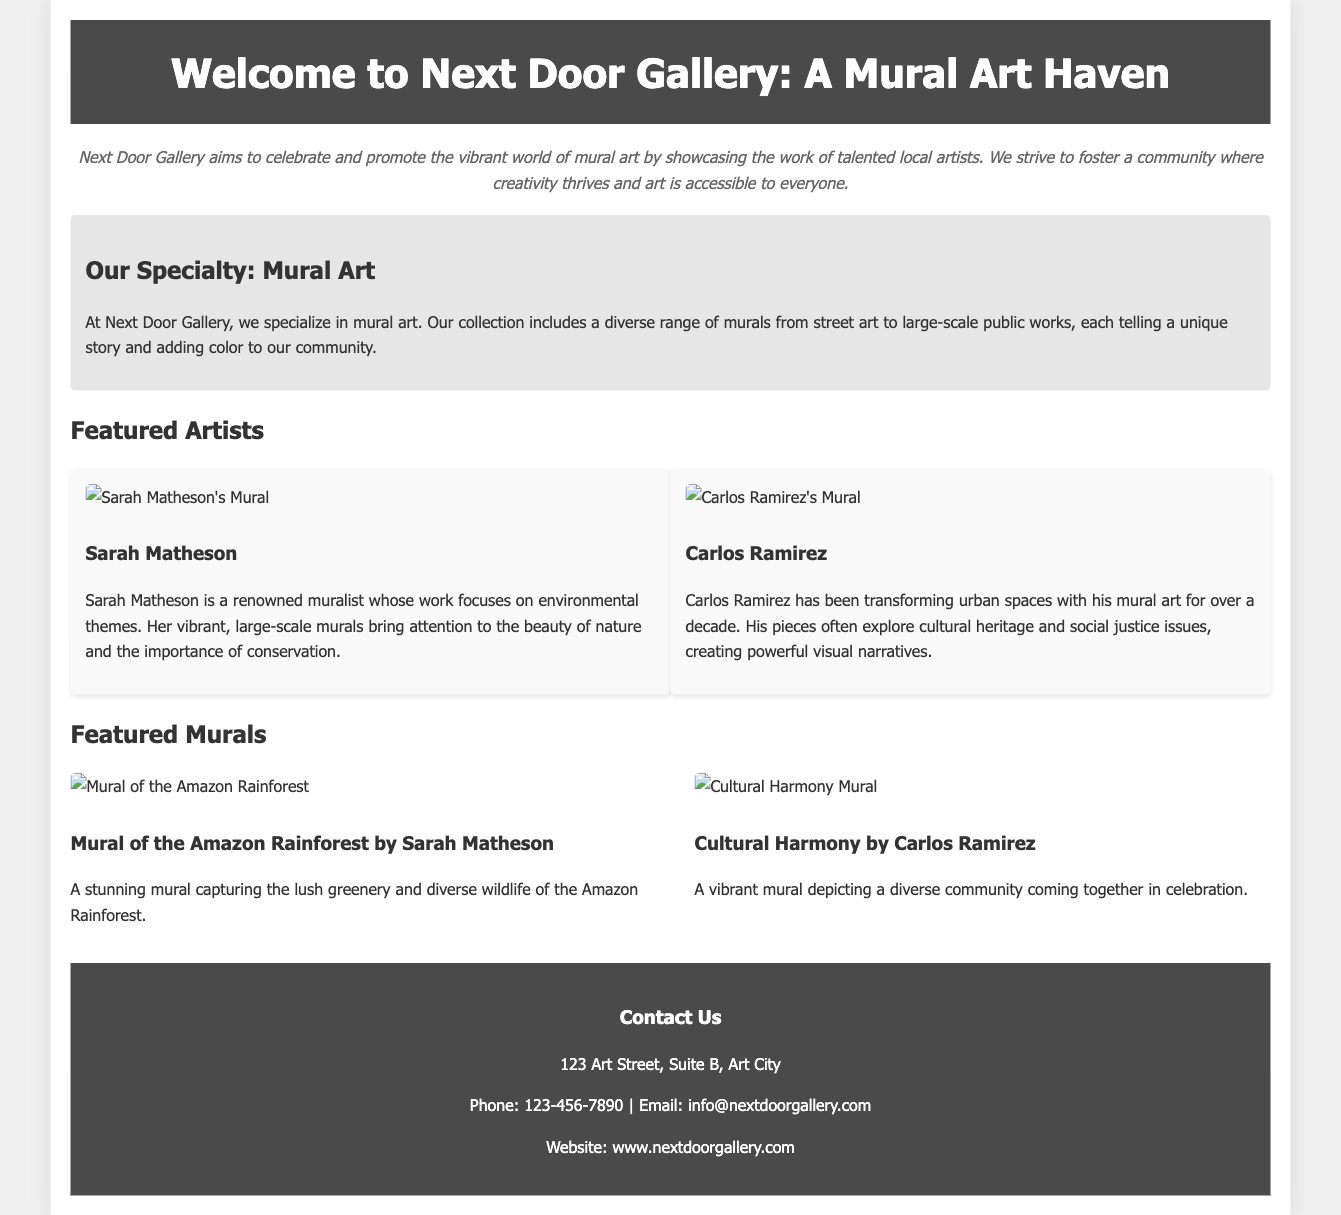What is the name of the gallery? The name of the gallery is mentioned in the document as "Next Door Gallery."
Answer: Next Door Gallery What is the gallery's mission? The mission of the gallery aims to celebrate and promote the vibrant world of mural art.
Answer: Celebrate and promote mural art Who are the featured artists? The document lists Sarah Matheson and Carlos Ramirez as the featured artists.
Answer: Sarah Matheson and Carlos Ramirez What theme does Sarah Matheson's work focus on? The document states that Sarah Matheson focuses on environmental themes in her murals.
Answer: Environmental themes How many murals are spotlighted in the gallery introduction? The document mentions two specific murals, one by each featured artist.
Answer: Two What type of art does Next Door Gallery specialize in? The document clearly states that the gallery specializes in mural art.
Answer: Mural art What is the phone number for the gallery? The document includes the phone number as 123-456-7890.
Answer: 123-456-7890 How is the brochure designed for durability? The document states that the brochure is laminated for durability and easy handling.
Answer: Laminated What is the address of the gallery? The address provided in the document is 123 Art Street, Suite B, Art City.
Answer: 123 Art Street, Suite B, Art City 